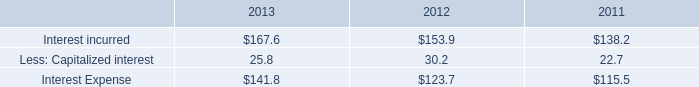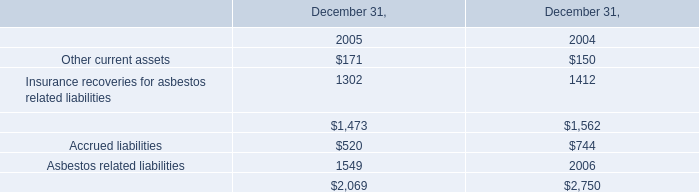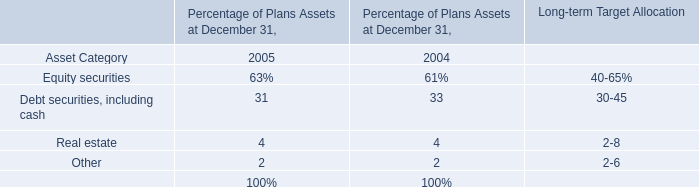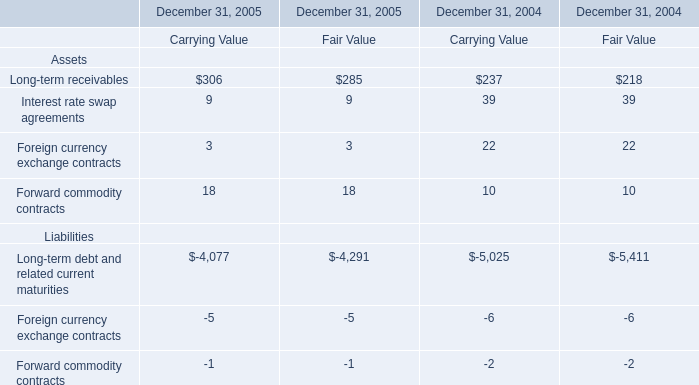In the year with the most Interest rate swap agreements, what is the growth rate of Forward commodity contracts? 
Computations: (((18 + 18) - (10 + 10)) / (10 + 10))
Answer: 0.8. 